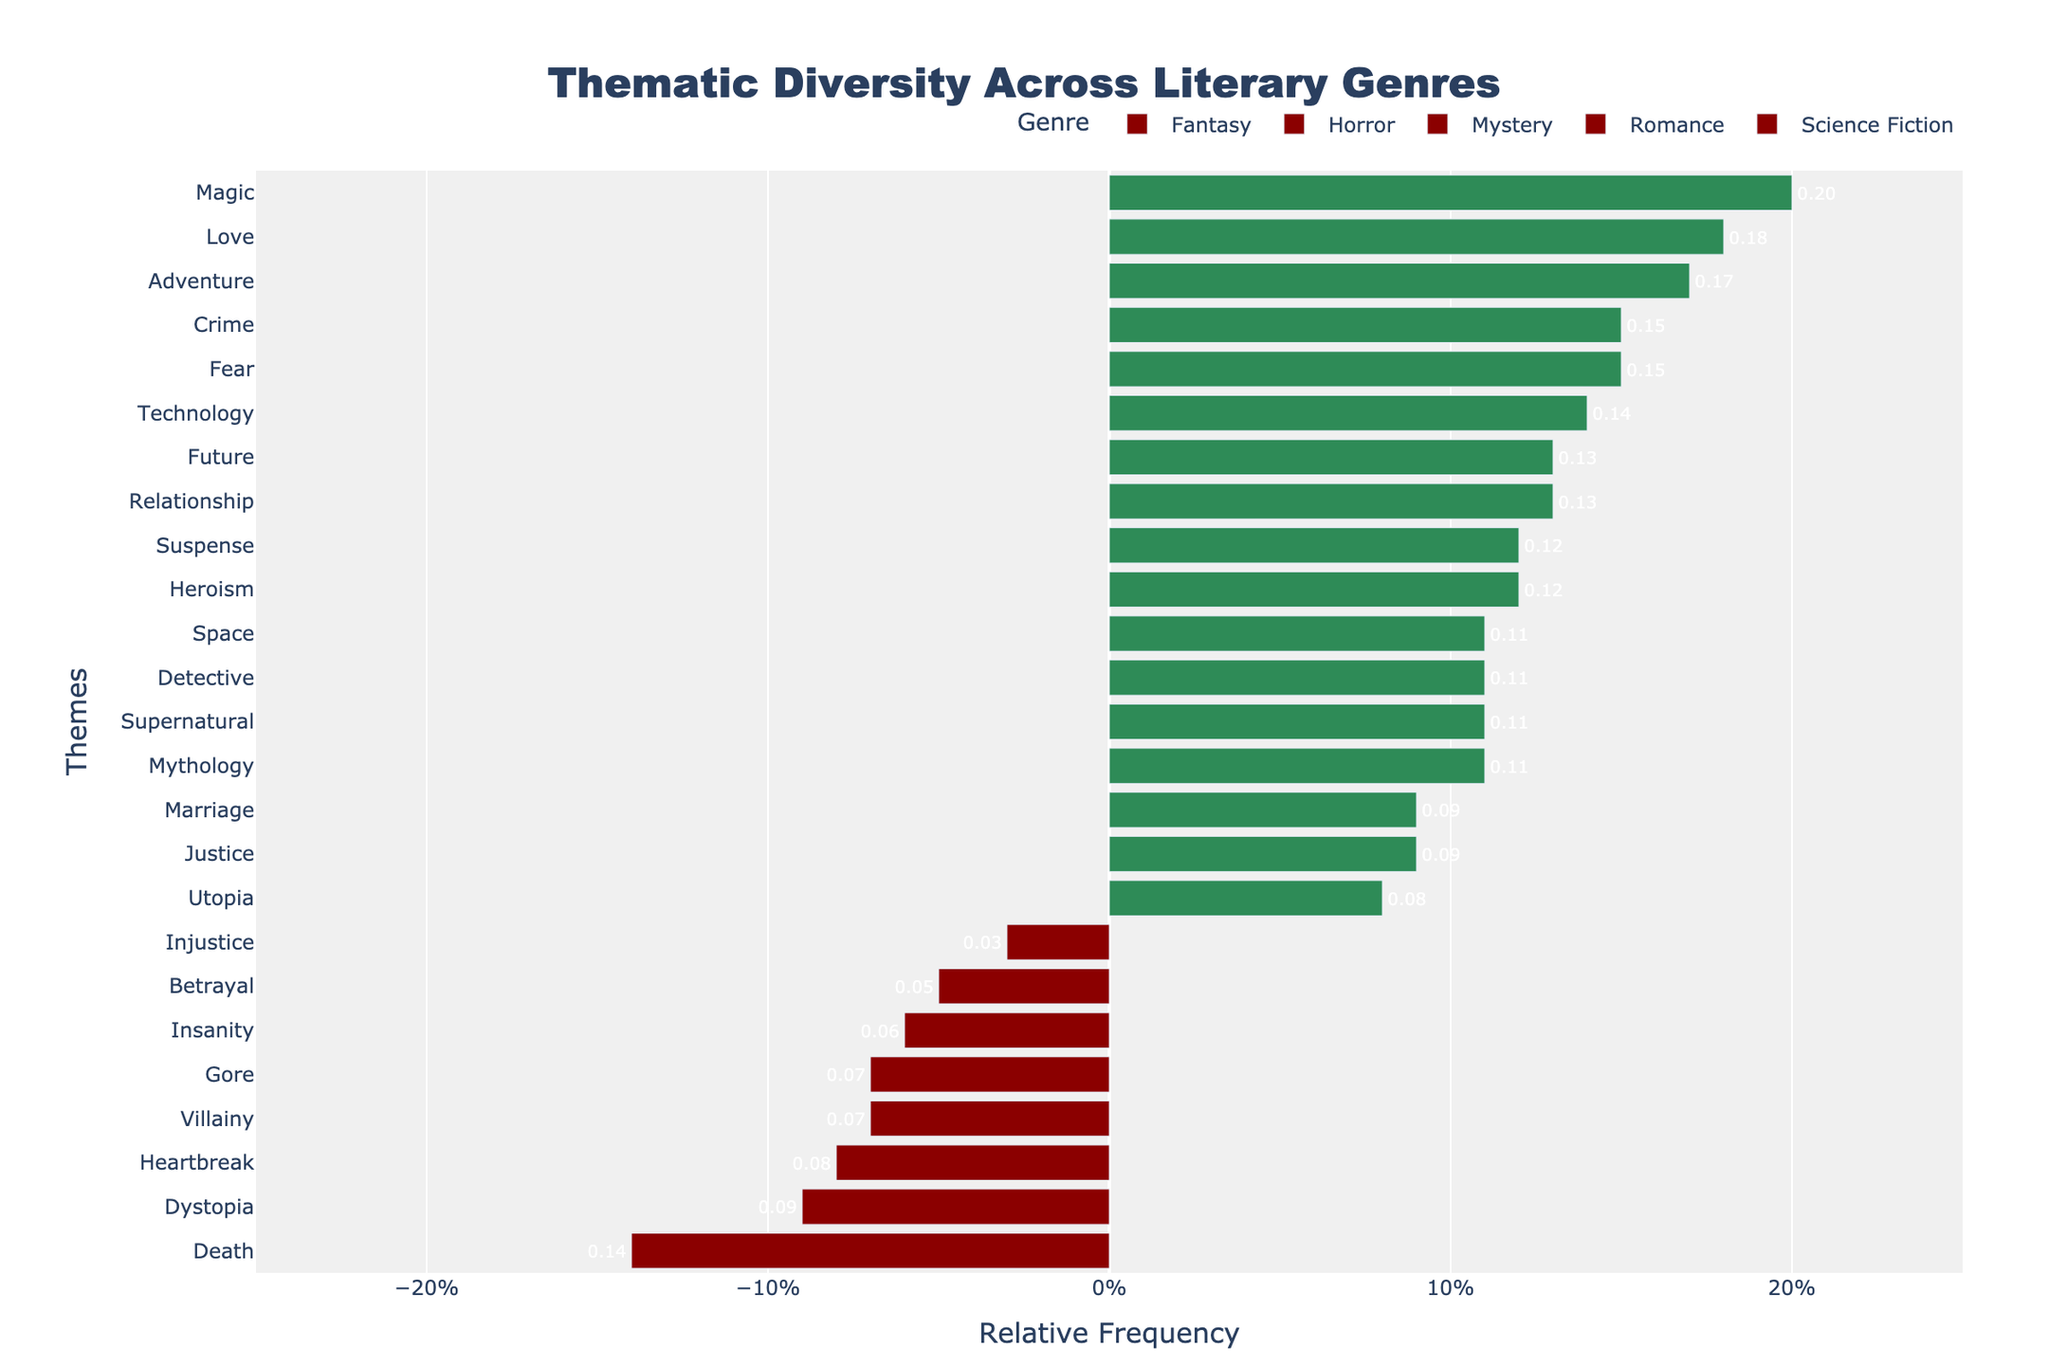How does the relative frequency of the theme 'Magic' in Fantasy compare to the theme 'Crime' in Mystery? The relative frequency of 'Magic' in Fantasy is 0.20, and for 'Crime' in Mystery, it is 0.15. Thus, 'Magic' has a higher relative frequency by 0.05.
Answer: 'Magic' in Fantasy has a higher relative frequency by 0.05 Which genre has the highest relative frequency for a negative-themed word, and what is it? By examining the negative-themed words in the figure, 'Death' in Horror has a relative frequency of 0.14, which is the highest among all negative themes across genres.
Answer: 'Horror' has the highest relative frequency for a negative-themed word: 'Death' with 0.14 What is the sum of the relative frequencies for positive themes in Science Fiction? In Science Fiction, the positive themes and their relative frequencies are 'Technology' (0.14), 'Future' (0.13), 'Utopia' (0.08), and 'Space' (0.11). Summing them up: 0.14 + 0.13 + 0.08 + 0.11 = 0.46.
Answer: 0.46 What is the difference in relative frequency between the themes 'Love' and 'Heartbreak' in Romance? 'Love' in Romance has a relative frequency of 0.18, and 'Heartbreak' has 0.08. The difference is 0.18 - 0.08 = 0.10.
Answer: 0.10 Which genre exhibits the most variability (greatest range) in its relative frequencies for negative themes? The negative themes in Fantasy range from 0.07 (Villainy) to 0.03 (Injustice), while Horror ranges from 0.14 (Death) to 0.06 (Insanity) and 0.07 (Gore). The range in Horror is 0.14 - 0.06 = 0.08, the largest among the listed genres.
Answer: Horror with a range of 0.08 Comparing 'Supernatural' in Horror and 'Space' in Science Fiction, which has a higher relative frequency and by how much? 'Supernatural' in Horror has a relative frequency of 0.11, while 'Space' in Science Fiction has 0.11 as well. Therefore, they both have the same relative frequency.
Answer: They have the same relative frequency How many themes in Mystery have a relative frequency greater than 0.10? In Mystery, the themes with relative frequencies greater than 0.10 are 'Crime' (0.15), 'Detective' (0.11), and 'Suspense' (0.12). Thus, there are three themes.
Answer: 3 Is there any genre where the relative frequency of 'Heroism' exceeds 0.10? In Fantasy, the theme 'Heroism' has a relative frequency of 0.12, which exceeds 0.10. No other genre lists 'Heroism'.
Answer: Yes, in Fantasy 